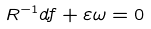Convert formula to latex. <formula><loc_0><loc_0><loc_500><loc_500>R ^ { - 1 } d f + \varepsilon \omega = 0</formula> 